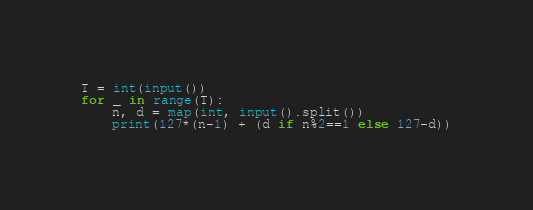<code> <loc_0><loc_0><loc_500><loc_500><_Python_>T = int(input())
for _ in range(T):
    n, d = map(int, input().split())
    print(127*(n-1) + (d if n%2==1 else 127-d))</code> 